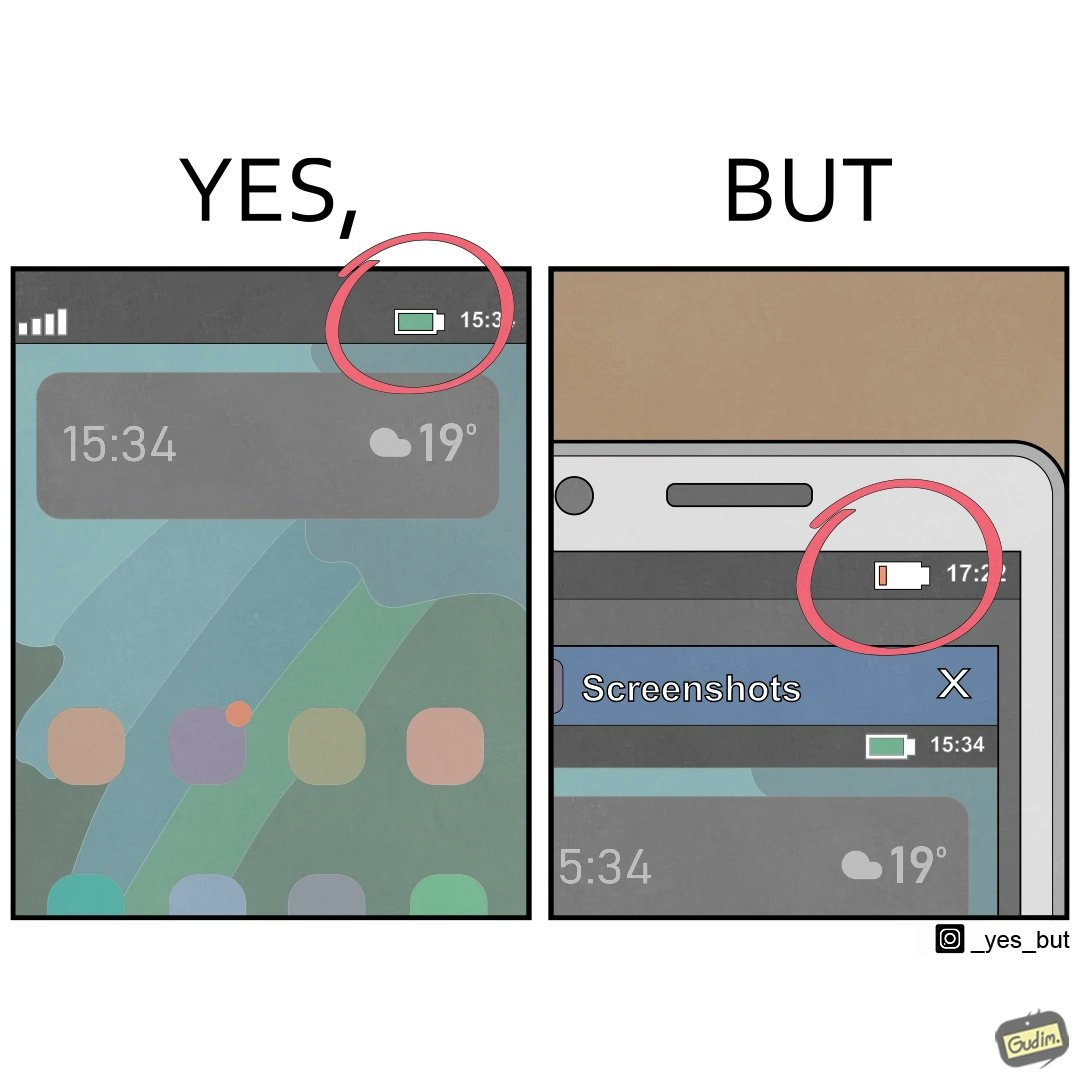Describe the content of this image. The image is ironic, because 